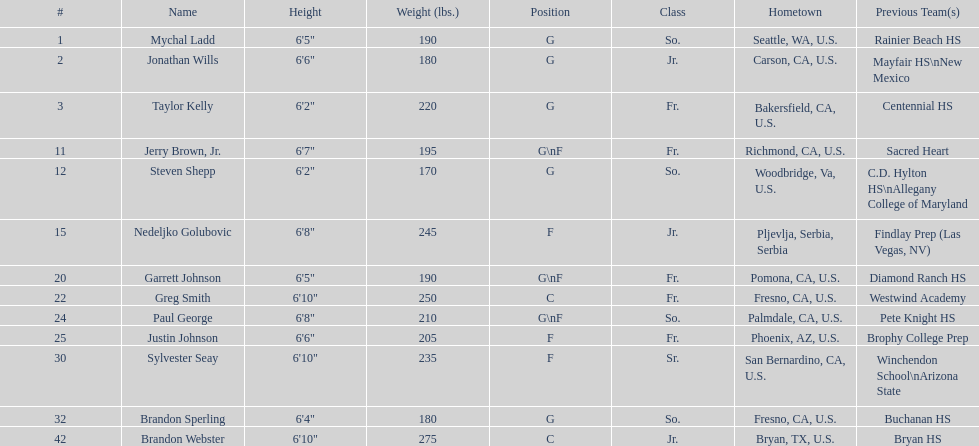Is the number of freshmen (fr.) greater than, equal to, or less than the number of juniors (jr.)? Greater. 